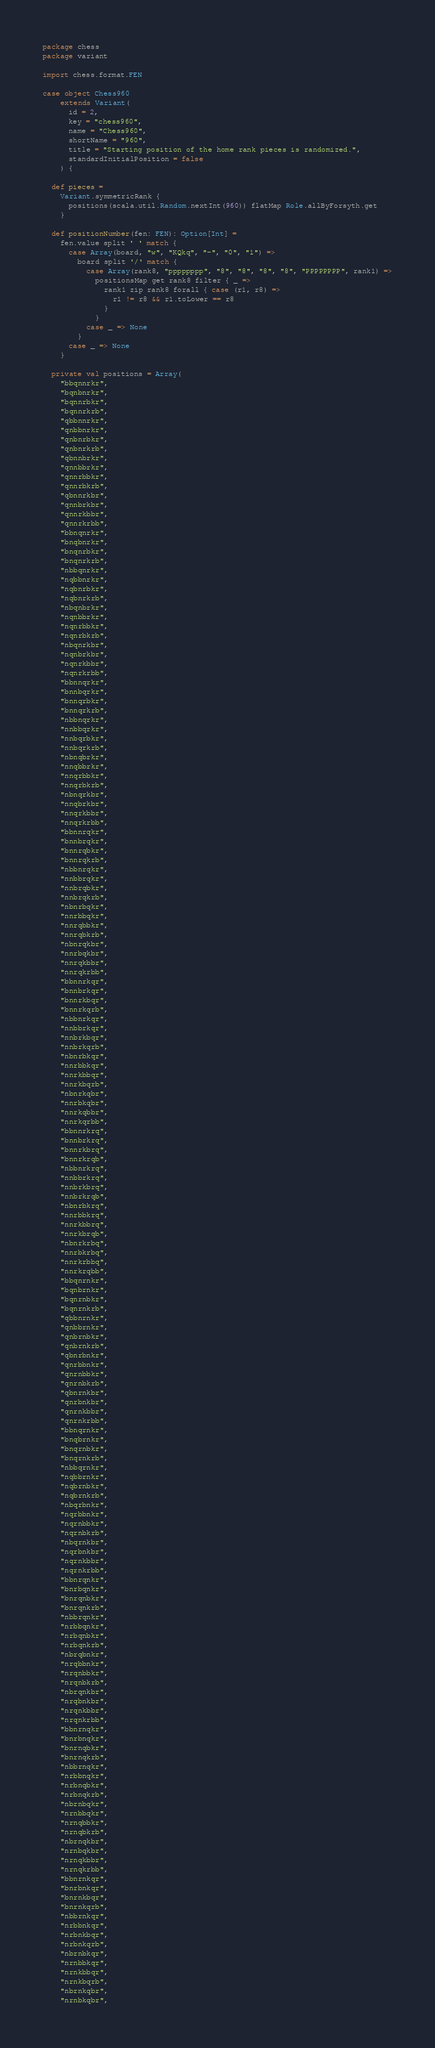<code> <loc_0><loc_0><loc_500><loc_500><_Scala_>package chess
package variant

import chess.format.FEN

case object Chess960
    extends Variant(
      id = 2,
      key = "chess960",
      name = "Chess960",
      shortName = "960",
      title = "Starting position of the home rank pieces is randomized.",
      standardInitialPosition = false
    ) {

  def pieces =
    Variant.symmetricRank {
      positions(scala.util.Random.nextInt(960)) flatMap Role.allByForsyth.get
    }

  def positionNumber(fen: FEN): Option[Int] =
    fen.value split ' ' match {
      case Array(board, "w", "KQkq", "-", "0", "1") =>
        board split '/' match {
          case Array(rank8, "pppppppp", "8", "8", "8", "8", "PPPPPPPP", rank1) =>
            positionsMap get rank8 filter { _ =>
              rank1 zip rank8 forall { case (r1, r8) =>
                r1 != r8 && r1.toLower == r8
              }
            }
          case _ => None
        }
      case _ => None
    }

  private val positions = Array(
    "bbqnnrkr",
    "bqnbnrkr",
    "bqnnrbkr",
    "bqnnrkrb",
    "qbbnnrkr",
    "qnbbnrkr",
    "qnbnrbkr",
    "qnbnrkrb",
    "qbnnbrkr",
    "qnnbbrkr",
    "qnnrbbkr",
    "qnnrbkrb",
    "qbnnrkbr",
    "qnnbrkbr",
    "qnnrkbbr",
    "qnnrkrbb",
    "bbnqnrkr",
    "bnqbnrkr",
    "bnqnrbkr",
    "bnqnrkrb",
    "nbbqnrkr",
    "nqbbnrkr",
    "nqbnrbkr",
    "nqbnrkrb",
    "nbqnbrkr",
    "nqnbbrkr",
    "nqnrbbkr",
    "nqnrbkrb",
    "nbqnrkbr",
    "nqnbrkbr",
    "nqnrkbbr",
    "nqnrkrbb",
    "bbnnqrkr",
    "bnnbqrkr",
    "bnnqrbkr",
    "bnnqrkrb",
    "nbbnqrkr",
    "nnbbqrkr",
    "nnbqrbkr",
    "nnbqrkrb",
    "nbnqbrkr",
    "nnqbbrkr",
    "nnqrbbkr",
    "nnqrbkrb",
    "nbnqrkbr",
    "nnqbrkbr",
    "nnqrkbbr",
    "nnqrkrbb",
    "bbnnrqkr",
    "bnnbrqkr",
    "bnnrqbkr",
    "bnnrqkrb",
    "nbbnrqkr",
    "nnbbrqkr",
    "nnbrqbkr",
    "nnbrqkrb",
    "nbnrbqkr",
    "nnrbbqkr",
    "nnrqbbkr",
    "nnrqbkrb",
    "nbnrqkbr",
    "nnrbqkbr",
    "nnrqkbbr",
    "nnrqkrbb",
    "bbnnrkqr",
    "bnnbrkqr",
    "bnnrkbqr",
    "bnnrkqrb",
    "nbbnrkqr",
    "nnbbrkqr",
    "nnbrkbqr",
    "nnbrkqrb",
    "nbnrbkqr",
    "nnrbbkqr",
    "nnrkbbqr",
    "nnrkbqrb",
    "nbnrkqbr",
    "nnrbkqbr",
    "nnrkqbbr",
    "nnrkqrbb",
    "bbnnrkrq",
    "bnnbrkrq",
    "bnnrkbrq",
    "bnnrkrqb",
    "nbbnrkrq",
    "nnbbrkrq",
    "nnbrkbrq",
    "nnbrkrqb",
    "nbnrbkrq",
    "nnrbbkrq",
    "nnrkbbrq",
    "nnrkbrqb",
    "nbnrkrbq",
    "nnrbkrbq",
    "nnrkrbbq",
    "nnrkrqbb",
    "bbqnrnkr",
    "bqnbrnkr",
    "bqnrnbkr",
    "bqnrnkrb",
    "qbbnrnkr",
    "qnbbrnkr",
    "qnbrnbkr",
    "qnbrnkrb",
    "qbnrbnkr",
    "qnrbbnkr",
    "qnrnbbkr",
    "qnrnbkrb",
    "qbnrnkbr",
    "qnrbnkbr",
    "qnrnkbbr",
    "qnrnkrbb",
    "bbnqrnkr",
    "bnqbrnkr",
    "bnqrnbkr",
    "bnqrnkrb",
    "nbbqrnkr",
    "nqbbrnkr",
    "nqbrnbkr",
    "nqbrnkrb",
    "nbqrbnkr",
    "nqrbbnkr",
    "nqrnbbkr",
    "nqrnbkrb",
    "nbqrnkbr",
    "nqrbnkbr",
    "nqrnkbbr",
    "nqrnkrbb",
    "bbnrqnkr",
    "bnrbqnkr",
    "bnrqnbkr",
    "bnrqnkrb",
    "nbbrqnkr",
    "nrbbqnkr",
    "nrbqnbkr",
    "nrbqnkrb",
    "nbrqbnkr",
    "nrqbbnkr",
    "nrqnbbkr",
    "nrqnbkrb",
    "nbrqnkbr",
    "nrqbnkbr",
    "nrqnkbbr",
    "nrqnkrbb",
    "bbnrnqkr",
    "bnrbnqkr",
    "bnrnqbkr",
    "bnrnqkrb",
    "nbbrnqkr",
    "nrbbnqkr",
    "nrbnqbkr",
    "nrbnqkrb",
    "nbrnbqkr",
    "nrnbbqkr",
    "nrnqbbkr",
    "nrnqbkrb",
    "nbrnqkbr",
    "nrnbqkbr",
    "nrnqkbbr",
    "nrnqkrbb",
    "bbnrnkqr",
    "bnrbnkqr",
    "bnrnkbqr",
    "bnrnkqrb",
    "nbbrnkqr",
    "nrbbnkqr",
    "nrbnkbqr",
    "nrbnkqrb",
    "nbrnbkqr",
    "nrnbbkqr",
    "nrnkbbqr",
    "nrnkbqrb",
    "nbrnkqbr",
    "nrnbkqbr",</code> 